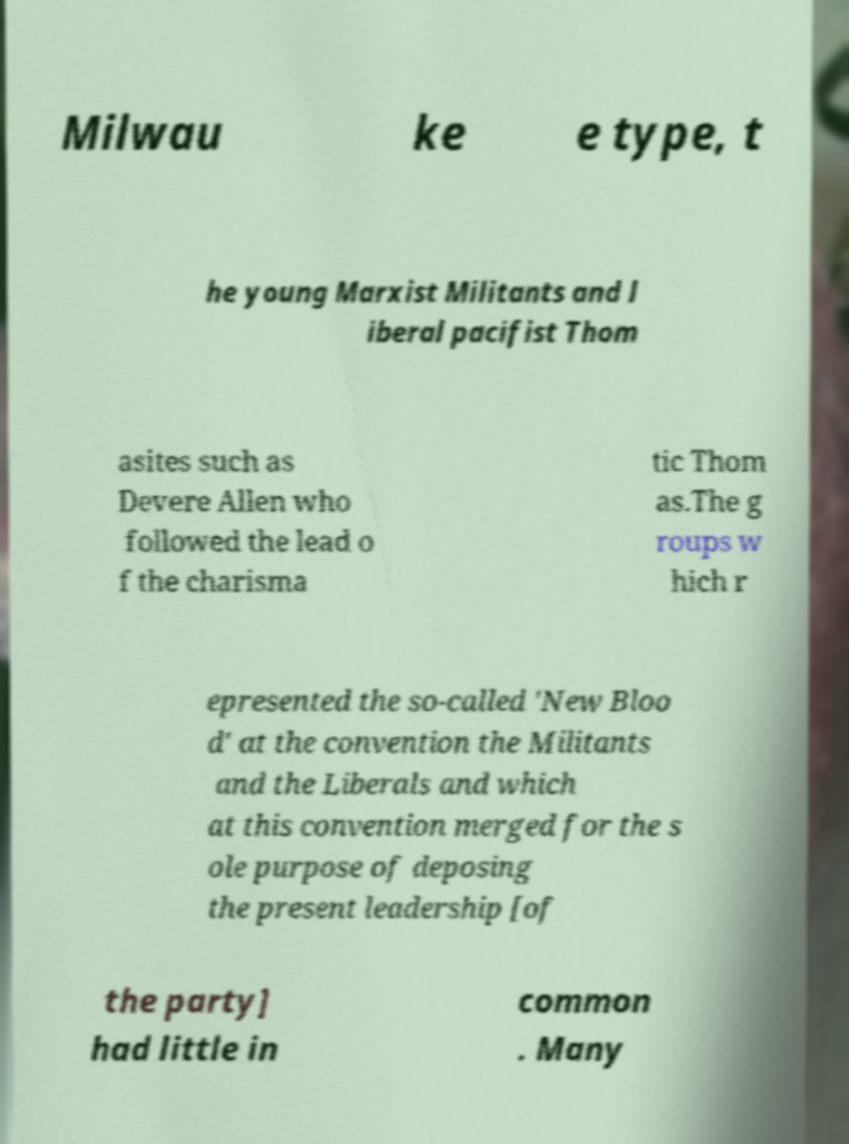What messages or text are displayed in this image? I need them in a readable, typed format. Milwau ke e type, t he young Marxist Militants and l iberal pacifist Thom asites such as Devere Allen who followed the lead o f the charisma tic Thom as.The g roups w hich r epresented the so-called 'New Bloo d' at the convention the Militants and the Liberals and which at this convention merged for the s ole purpose of deposing the present leadership [of the party] had little in common . Many 